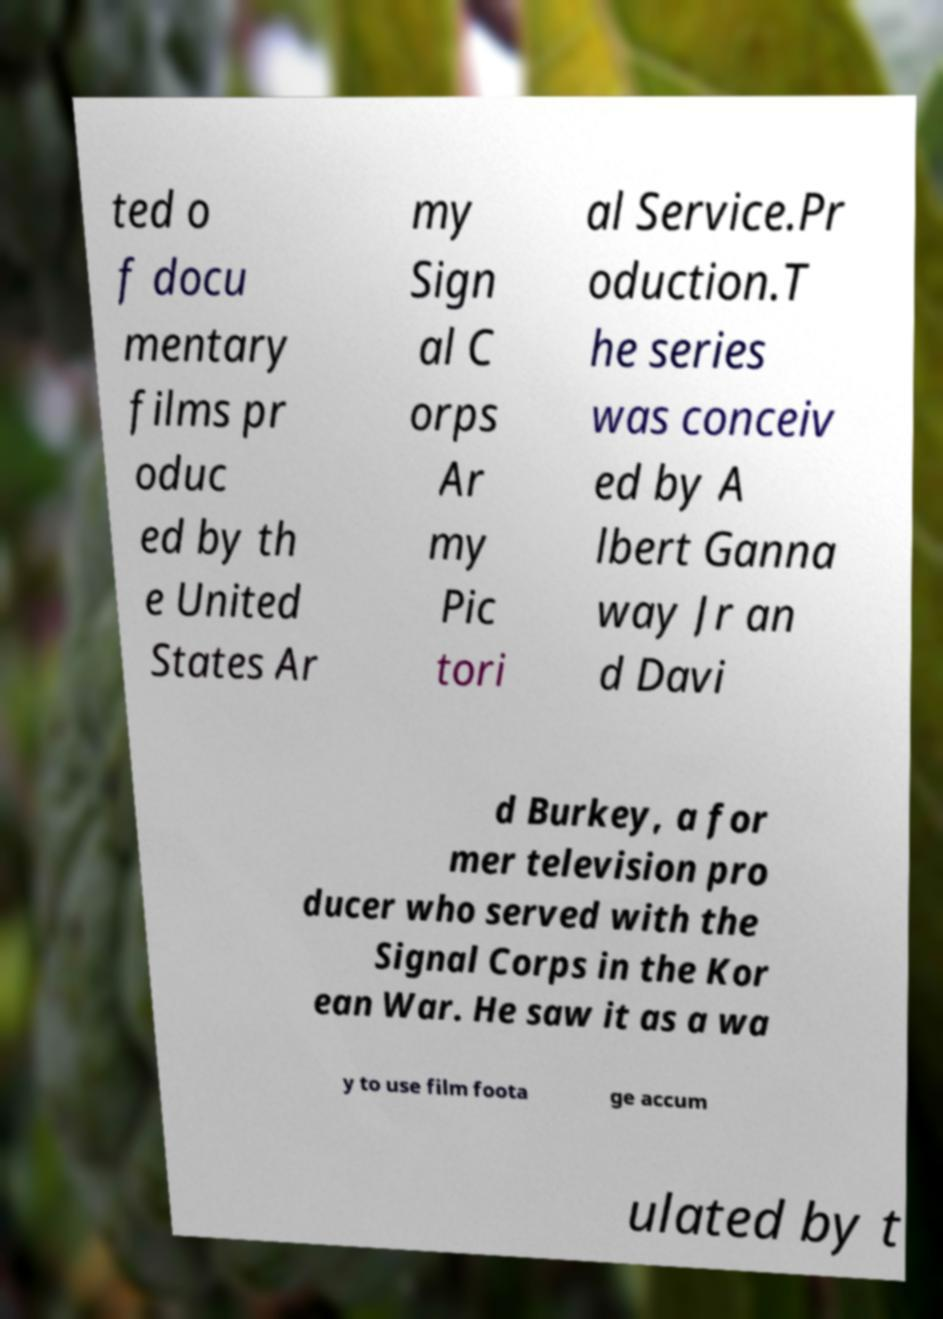Could you extract and type out the text from this image? ted o f docu mentary films pr oduc ed by th e United States Ar my Sign al C orps Ar my Pic tori al Service.Pr oduction.T he series was conceiv ed by A lbert Ganna way Jr an d Davi d Burkey, a for mer television pro ducer who served with the Signal Corps in the Kor ean War. He saw it as a wa y to use film foota ge accum ulated by t 